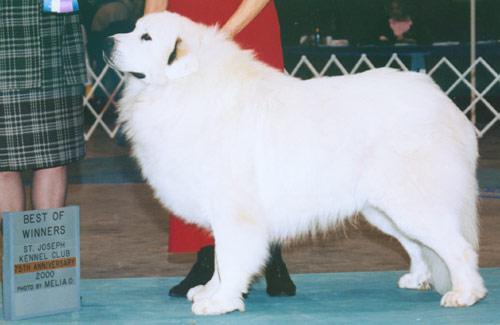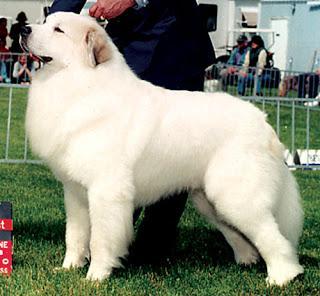The first image is the image on the left, the second image is the image on the right. Examine the images to the left and right. Is the description "All of the white dogs are facing leftward, and one dog is posed on green grass." accurate? Answer yes or no. Yes. The first image is the image on the left, the second image is the image on the right. Assess this claim about the two images: "In one image a dog is sitting down and in the other image the dog is standing.". Correct or not? Answer yes or no. No. 